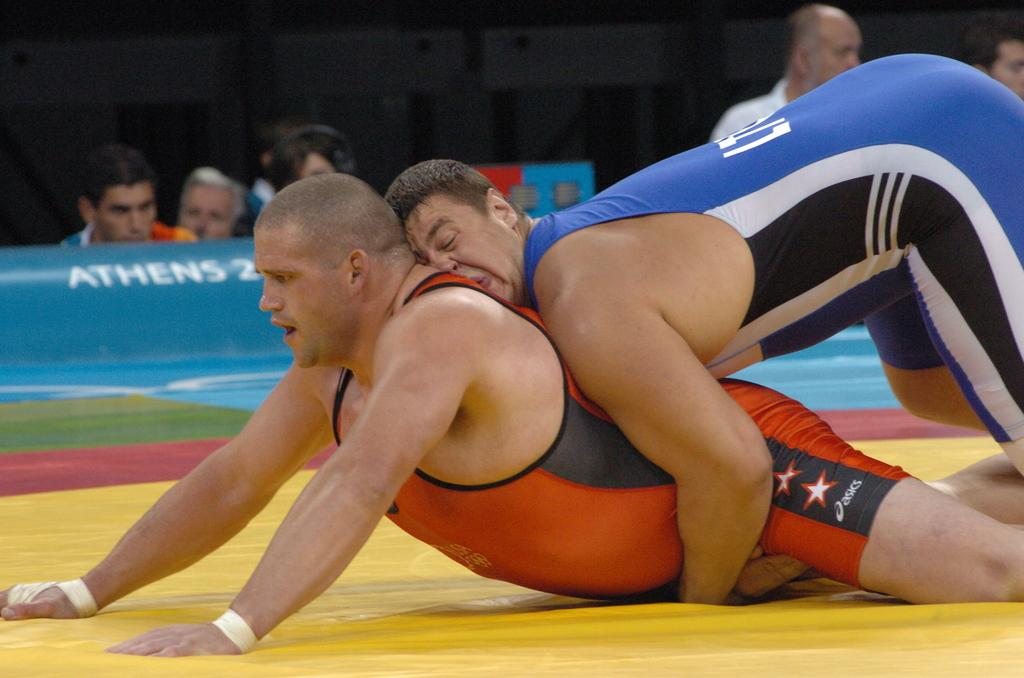Provide a one-sentence caption for the provided image. Two men wrestleing on a mat in Athens. 